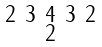Convert formula to latex. <formula><loc_0><loc_0><loc_500><loc_500>\begin{smallmatrix} 2 & 3 & 4 & 3 & 2 \\ & & 2 & & \end{smallmatrix}</formula> 